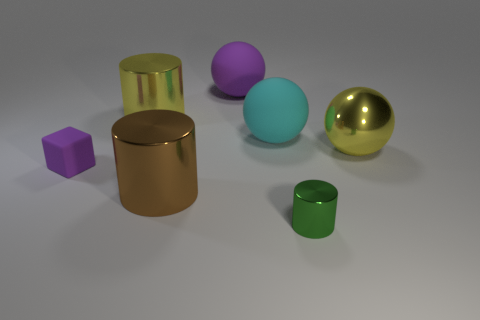The cyan rubber thing that is the same shape as the big purple object is what size?
Provide a short and direct response. Large. Is the number of tiny cubes that are in front of the cyan sphere greater than the number of tiny green shiny cylinders in front of the small green thing?
Offer a terse response. Yes. Are the large purple ball and the big yellow thing left of the yellow ball made of the same material?
Your response must be concise. No. Is there anything else that is the same shape as the small green thing?
Provide a succinct answer. Yes. There is a big metallic object that is in front of the cyan rubber ball and to the left of the metal sphere; what color is it?
Make the answer very short. Brown. There is a large metal object in front of the purple cube; what shape is it?
Provide a short and direct response. Cylinder. What is the size of the purple thing on the left side of the large cylinder that is in front of the big yellow thing that is on the left side of the big purple matte object?
Your answer should be very brief. Small. There is a yellow object behind the big metallic ball; how many shiny objects are right of it?
Give a very brief answer. 3. There is a metal thing that is on the right side of the brown metal object and behind the small green cylinder; how big is it?
Offer a terse response. Large. What number of shiny objects are large purple balls or green cylinders?
Keep it short and to the point. 1. 